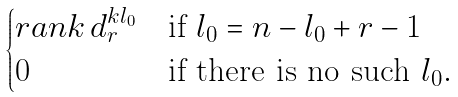<formula> <loc_0><loc_0><loc_500><loc_500>\begin{cases} r a n k \, d ^ { k l _ { 0 } } _ { r } & \text {if $l_{0}=n-l_{0}+r-1$} \\ 0 & \text {if there is no such $l_{0}.$} \\ \end{cases}</formula> 